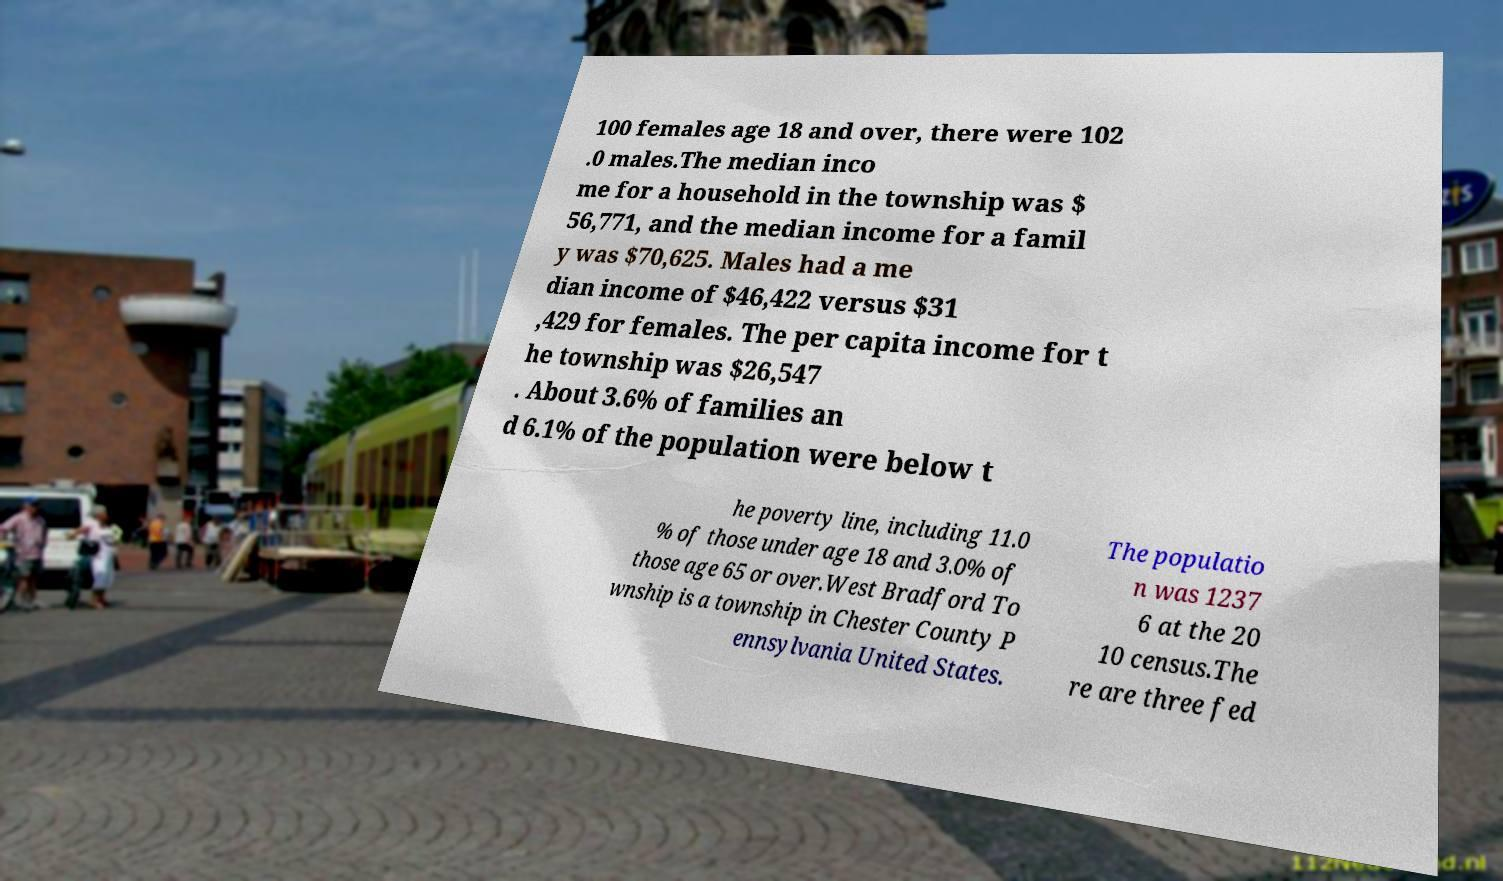Could you assist in decoding the text presented in this image and type it out clearly? 100 females age 18 and over, there were 102 .0 males.The median inco me for a household in the township was $ 56,771, and the median income for a famil y was $70,625. Males had a me dian income of $46,422 versus $31 ,429 for females. The per capita income for t he township was $26,547 . About 3.6% of families an d 6.1% of the population were below t he poverty line, including 11.0 % of those under age 18 and 3.0% of those age 65 or over.West Bradford To wnship is a township in Chester County P ennsylvania United States. The populatio n was 1237 6 at the 20 10 census.The re are three fed 